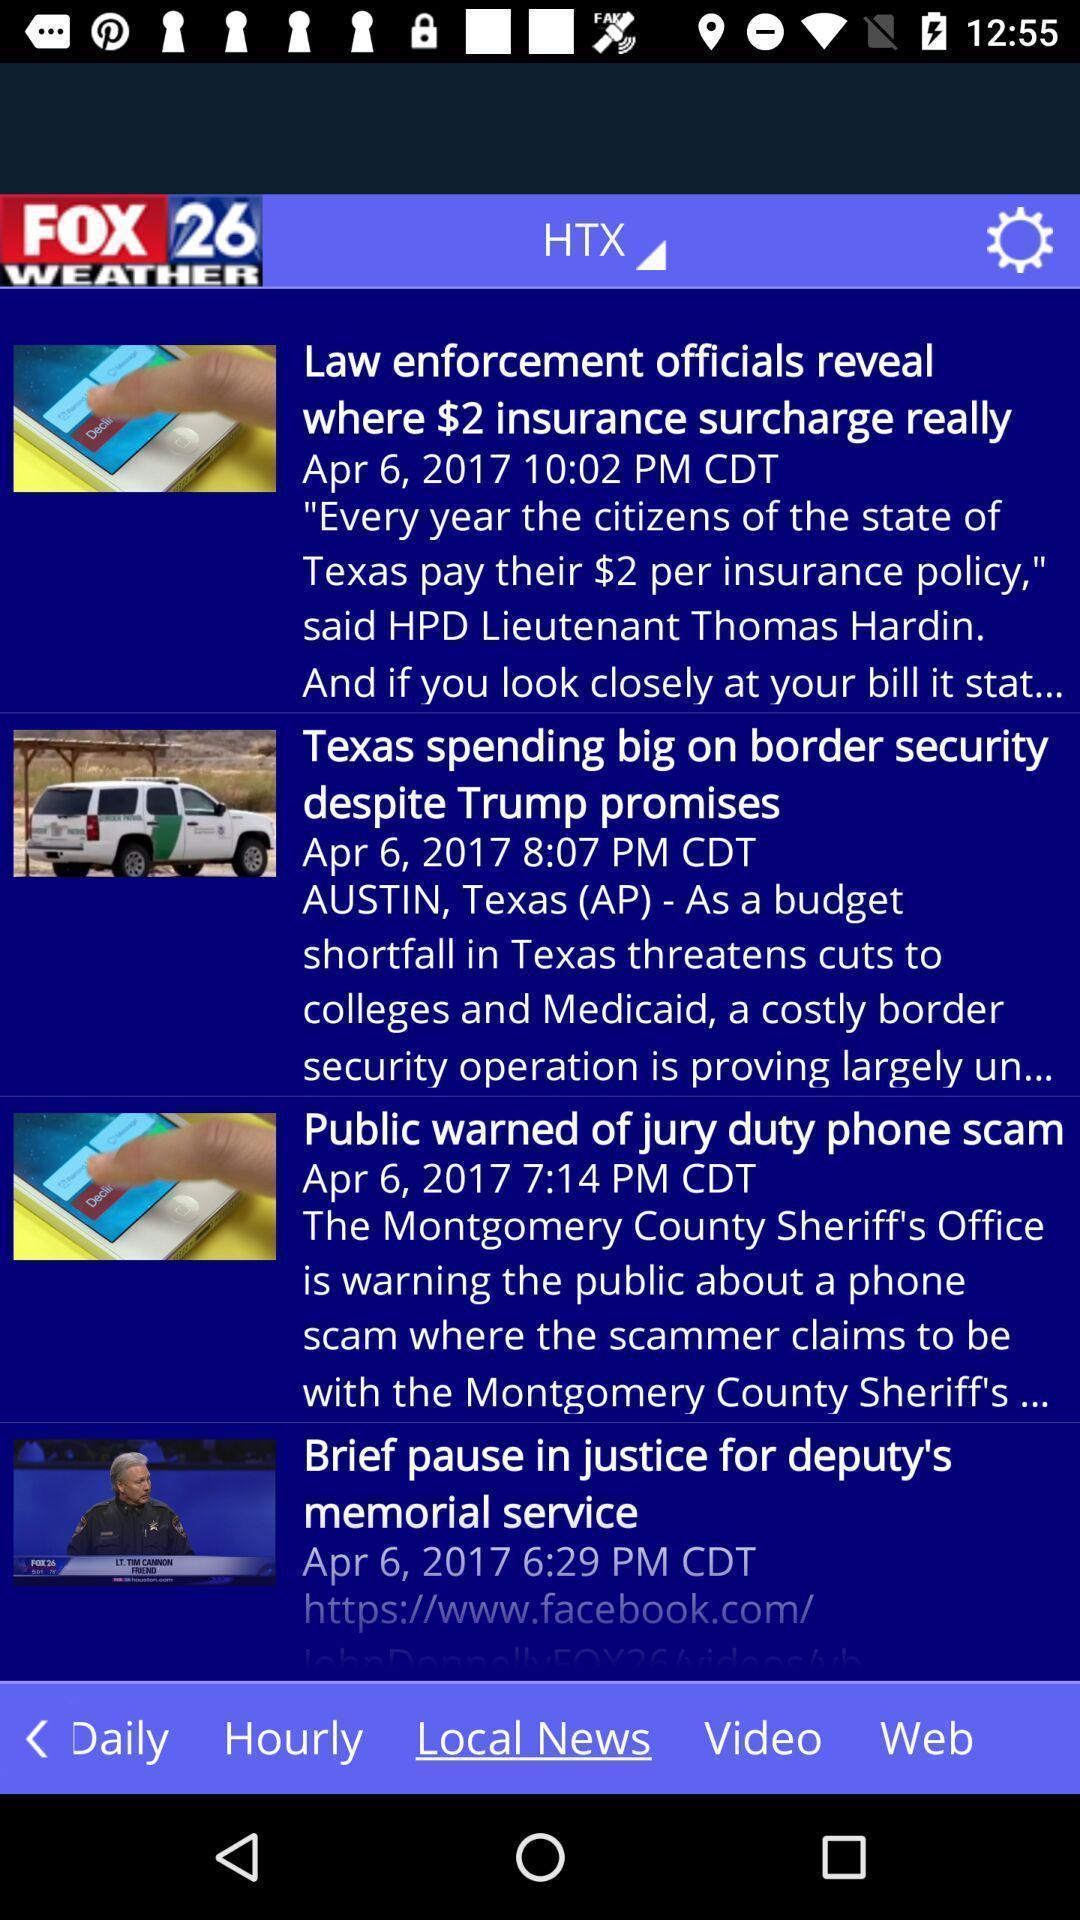Give me a summary of this screen capture. Screen shows news articles. 